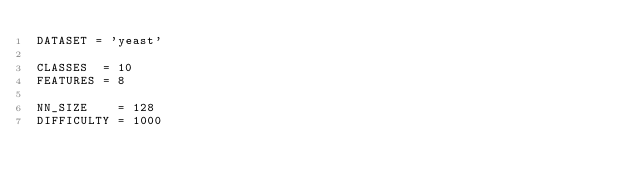Convert code to text. <code><loc_0><loc_0><loc_500><loc_500><_Python_>DATASET = 'yeast'

CLASSES  = 10
FEATURES = 8

NN_SIZE    = 128
DIFFICULTY = 1000</code> 